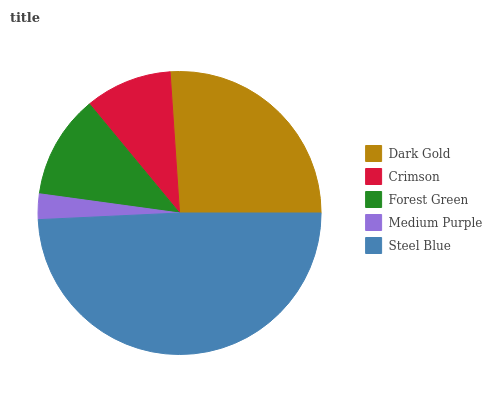Is Medium Purple the minimum?
Answer yes or no. Yes. Is Steel Blue the maximum?
Answer yes or no. Yes. Is Crimson the minimum?
Answer yes or no. No. Is Crimson the maximum?
Answer yes or no. No. Is Dark Gold greater than Crimson?
Answer yes or no. Yes. Is Crimson less than Dark Gold?
Answer yes or no. Yes. Is Crimson greater than Dark Gold?
Answer yes or no. No. Is Dark Gold less than Crimson?
Answer yes or no. No. Is Forest Green the high median?
Answer yes or no. Yes. Is Forest Green the low median?
Answer yes or no. Yes. Is Dark Gold the high median?
Answer yes or no. No. Is Crimson the low median?
Answer yes or no. No. 